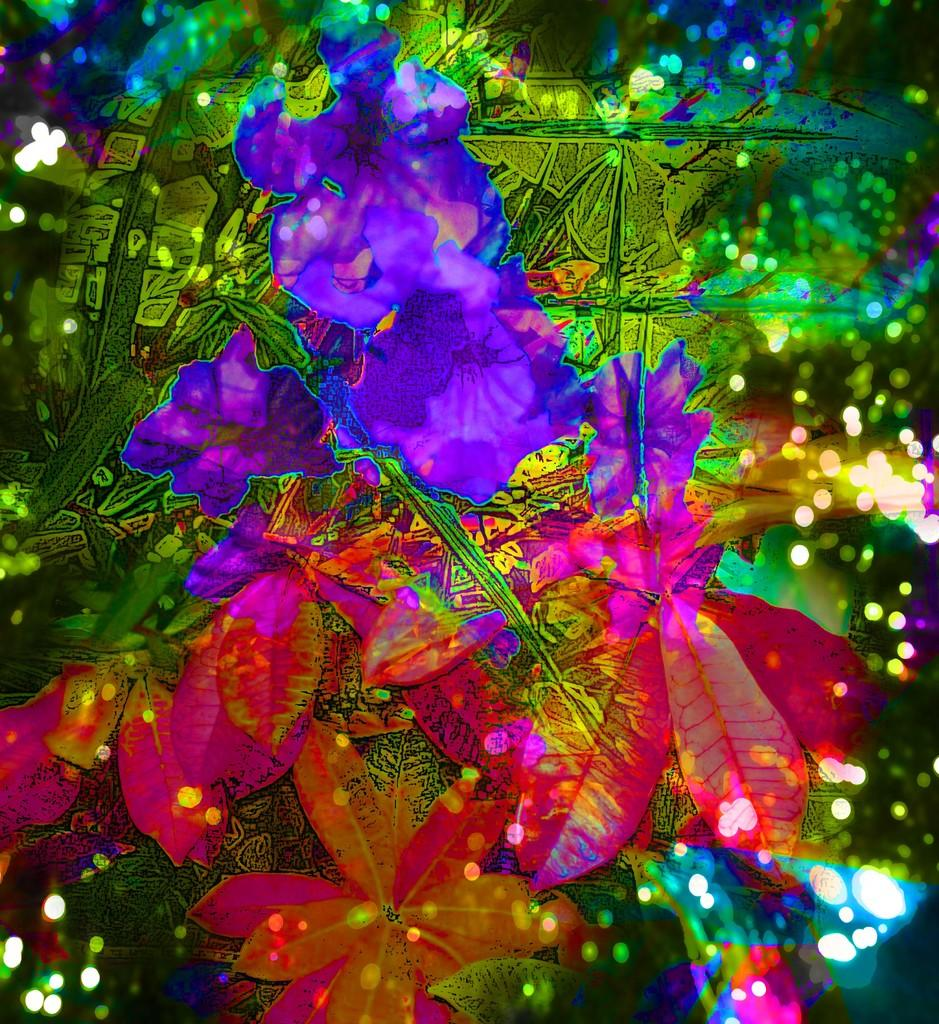What type of picture is in the image? The image contains an edited picture. What can be seen in the edited picture? There are flowers and colorful trees in the edited picture. What historical event is depicted in the image? There is no historical event depicted in the image; it contains an edited picture with flowers and colorful trees. Can you see any icicles hanging from the trees in the image? There are no icicles present in the image; the trees are colorful and not covered in ice. 